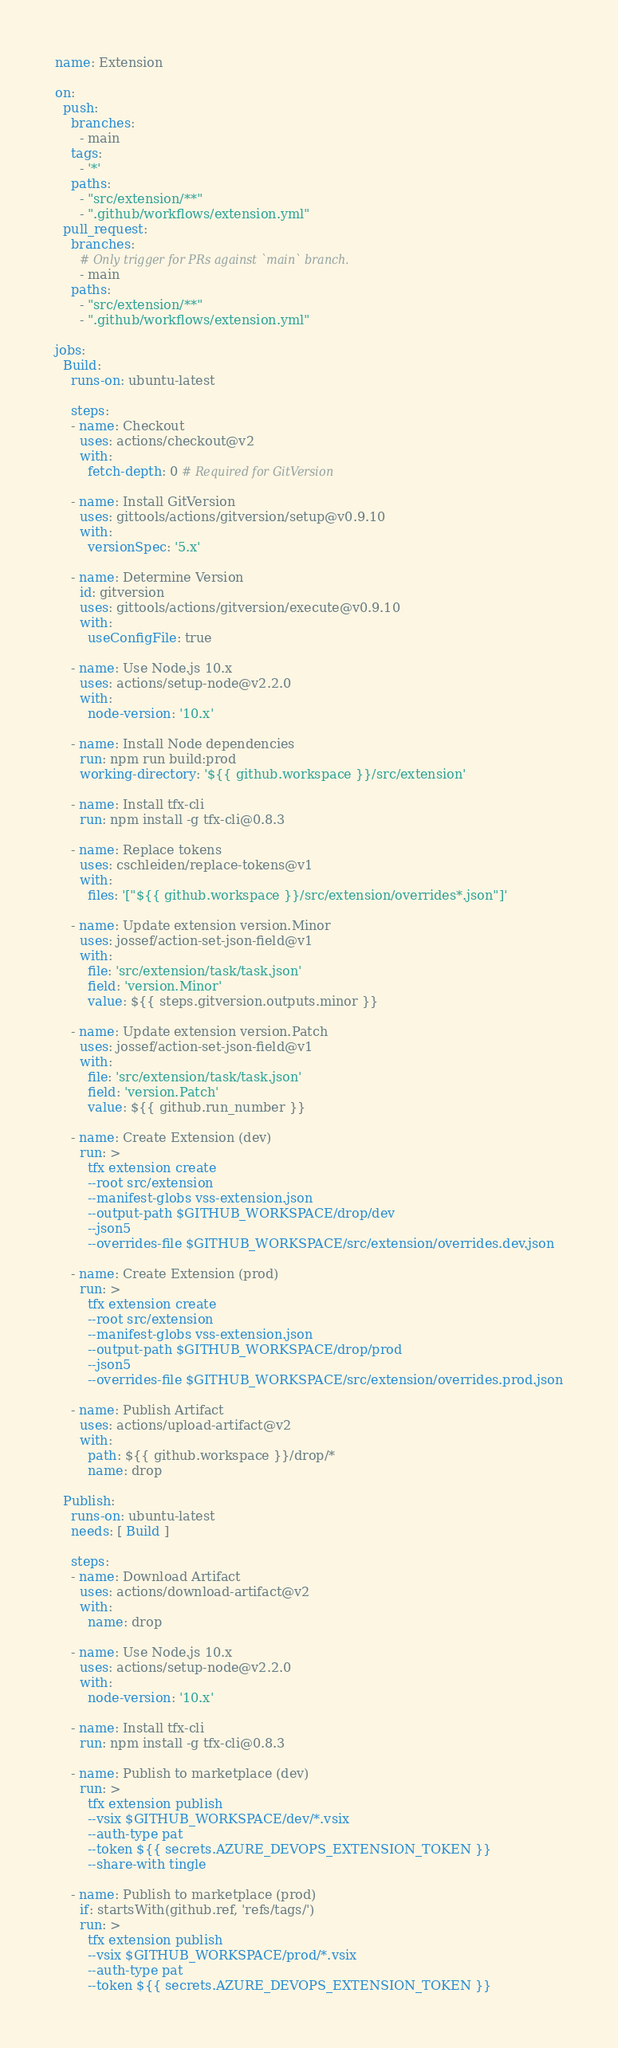Convert code to text. <code><loc_0><loc_0><loc_500><loc_500><_YAML_>name: Extension

on:
  push:
    branches:
      - main
    tags:
      - '*'
    paths:
      - "src/extension/**"
      - ".github/workflows/extension.yml"
  pull_request:
    branches:
      # Only trigger for PRs against `main` branch.
      - main
    paths:
      - "src/extension/**"
      - ".github/workflows/extension.yml"

jobs:
  Build:
    runs-on: ubuntu-latest

    steps:
    - name: Checkout
      uses: actions/checkout@v2
      with:
        fetch-depth: 0 # Required for GitVersion

    - name: Install GitVersion
      uses: gittools/actions/gitversion/setup@v0.9.10
      with:
        versionSpec: '5.x'

    - name: Determine Version
      id: gitversion
      uses: gittools/actions/gitversion/execute@v0.9.10
      with:
        useConfigFile: true

    - name: Use Node.js 10.x
      uses: actions/setup-node@v2.2.0
      with:
        node-version: '10.x'

    - name: Install Node dependencies
      run: npm run build:prod
      working-directory: '${{ github.workspace }}/src/extension'

    - name: Install tfx-cli
      run: npm install -g tfx-cli@0.8.3

    - name: Replace tokens
      uses: cschleiden/replace-tokens@v1
      with:
        files: '["${{ github.workspace }}/src/extension/overrides*.json"]'

    - name: Update extension version.Minor
      uses: jossef/action-set-json-field@v1
      with:
        file: 'src/extension/task/task.json'
        field: 'version.Minor'
        value: ${{ steps.gitversion.outputs.minor }}

    - name: Update extension version.Patch
      uses: jossef/action-set-json-field@v1
      with:
        file: 'src/extension/task/task.json'
        field: 'version.Patch'
        value: ${{ github.run_number }}

    - name: Create Extension (dev)
      run: >
        tfx extension create
        --root src/extension
        --manifest-globs vss-extension.json
        --output-path $GITHUB_WORKSPACE/drop/dev
        --json5
        --overrides-file $GITHUB_WORKSPACE/src/extension/overrides.dev.json

    - name: Create Extension (prod)
      run: >
        tfx extension create
        --root src/extension
        --manifest-globs vss-extension.json
        --output-path $GITHUB_WORKSPACE/drop/prod
        --json5
        --overrides-file $GITHUB_WORKSPACE/src/extension/overrides.prod.json

    - name: Publish Artifact
      uses: actions/upload-artifact@v2
      with:
        path: ${{ github.workspace }}/drop/*
        name: drop

  Publish:
    runs-on: ubuntu-latest
    needs: [ Build ]

    steps:
    - name: Download Artifact
      uses: actions/download-artifact@v2
      with:
        name: drop

    - name: Use Node.js 10.x
      uses: actions/setup-node@v2.2.0
      with:
        node-version: '10.x'

    - name: Install tfx-cli
      run: npm install -g tfx-cli@0.8.3

    - name: Publish to marketplace (dev)
      run: >
        tfx extension publish
        --vsix $GITHUB_WORKSPACE/dev/*.vsix
        --auth-type pat
        --token ${{ secrets.AZURE_DEVOPS_EXTENSION_TOKEN }}
        --share-with tingle

    - name: Publish to marketplace (prod)
      if: startsWith(github.ref, 'refs/tags/')
      run: >
        tfx extension publish
        --vsix $GITHUB_WORKSPACE/prod/*.vsix
        --auth-type pat
        --token ${{ secrets.AZURE_DEVOPS_EXTENSION_TOKEN }}
</code> 